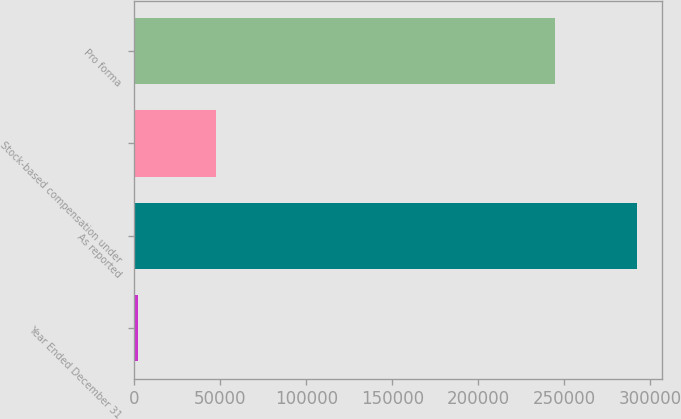Convert chart. <chart><loc_0><loc_0><loc_500><loc_500><bar_chart><fcel>Year Ended December 31<fcel>As reported<fcel>Stock-based compensation under<fcel>Pro forma<nl><fcel>2002<fcel>292435<fcel>47761<fcel>244674<nl></chart> 